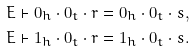<formula> <loc_0><loc_0><loc_500><loc_500>& E \vdash 0 _ { h } \cdot 0 _ { t } \cdot r = 0 _ { h } \cdot 0 _ { t } \cdot s , \\ & E \vdash 1 _ { h } \cdot 0 _ { t } \cdot r = 1 _ { h } \cdot 0 _ { t } \cdot s .</formula> 